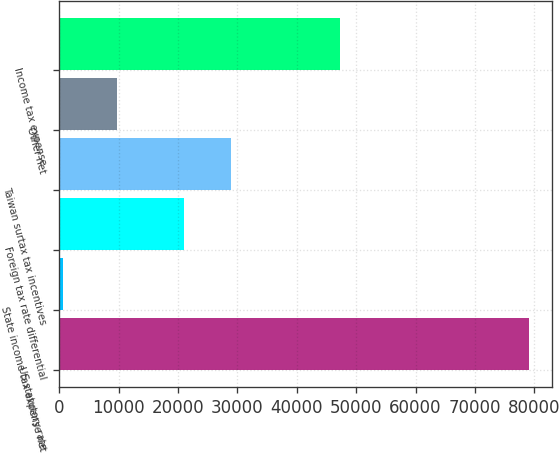Convert chart to OTSL. <chart><loc_0><loc_0><loc_500><loc_500><bar_chart><fcel>US statutory rate<fcel>State income tax expense net<fcel>Foreign tax rate differential<fcel>Taiwan surtax tax incentives<fcel>Other net<fcel>Income tax expense<nl><fcel>79080<fcel>626<fcel>21038<fcel>28883.4<fcel>9802<fcel>47309<nl></chart> 